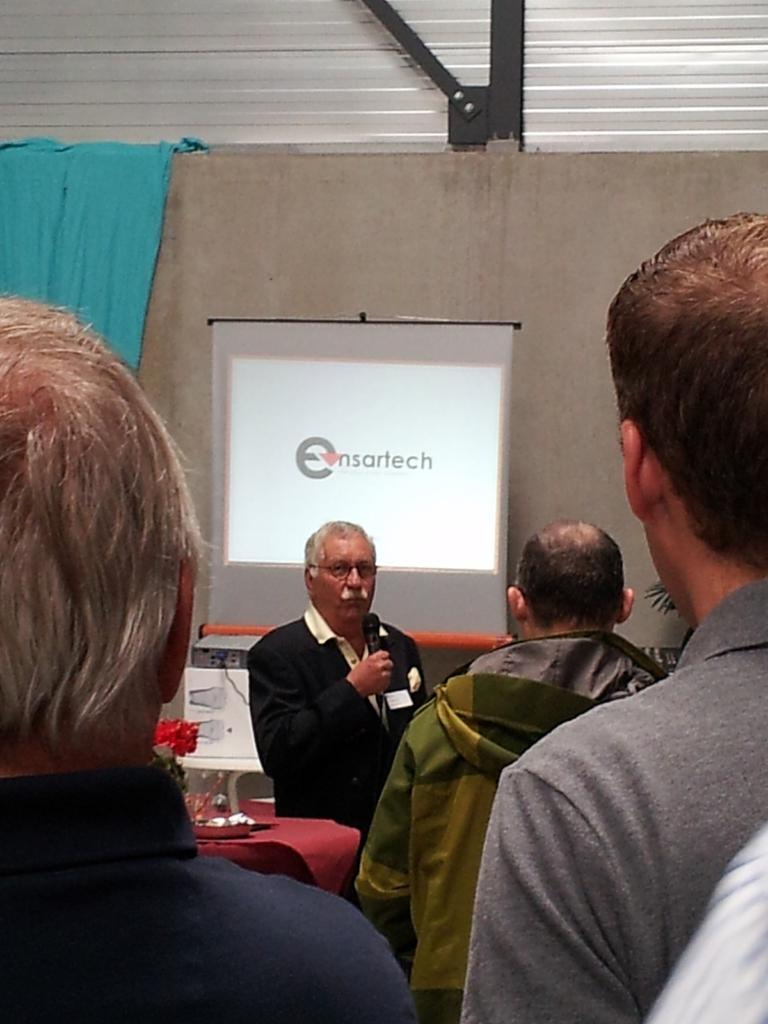What are the people in the image doing? The people in the image are standing. Can you describe the person holding a specific object? One person is holding a microphone. What can be seen in the background of the image? There are objects, a screen, and a wall visible in the background. What color is the cloth on the wall? There is a blue cloth on the wall. What type of celery is being used as a prop in the image? There is no celery present in the image. What scientific theory is being discussed by the people in the image? The image does not provide any information about a scientific theory being discussed. 